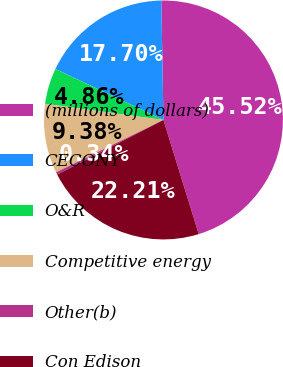Convert chart. <chart><loc_0><loc_0><loc_500><loc_500><pie_chart><fcel>(millions of dollars)<fcel>CECONY<fcel>O&R<fcel>Competitive energy<fcel>Other(b)<fcel>Con Edison<nl><fcel>45.52%<fcel>17.7%<fcel>4.86%<fcel>9.38%<fcel>0.34%<fcel>22.21%<nl></chart> 